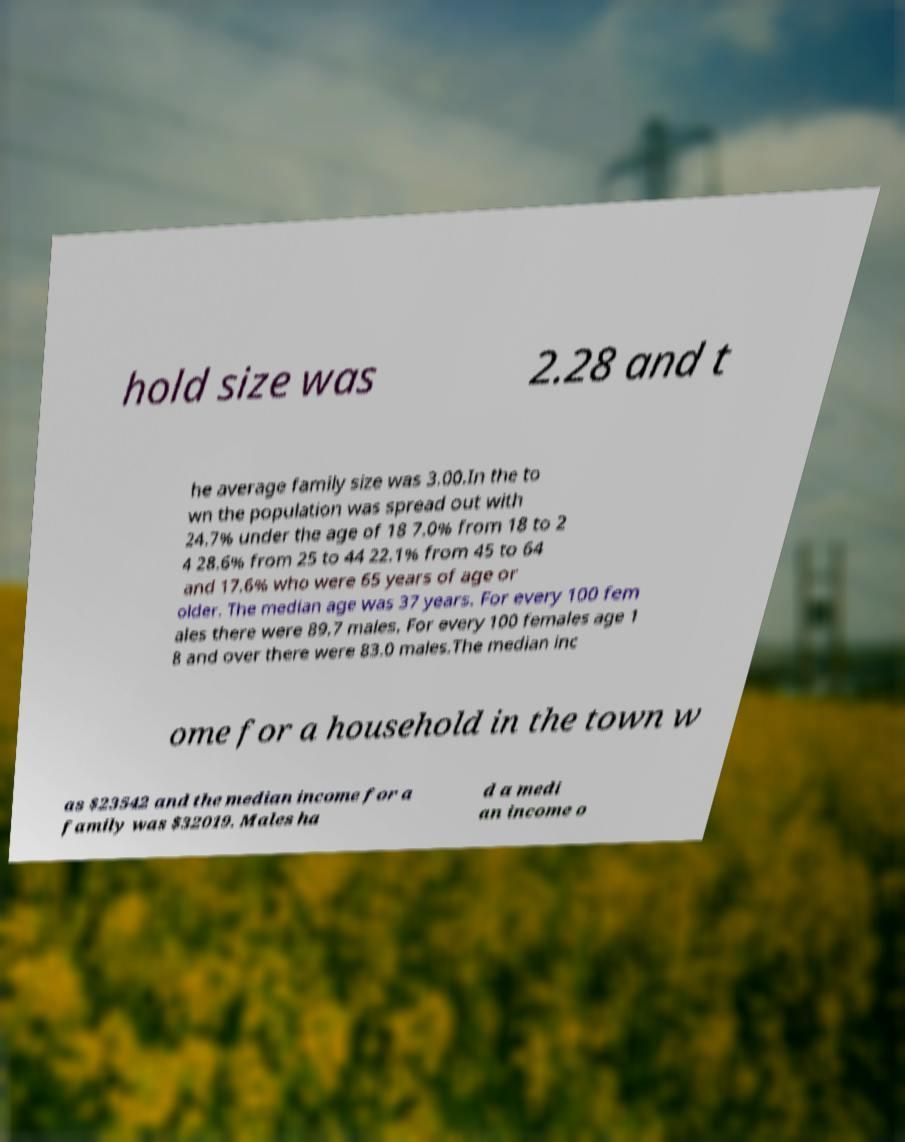There's text embedded in this image that I need extracted. Can you transcribe it verbatim? hold size was 2.28 and t he average family size was 3.00.In the to wn the population was spread out with 24.7% under the age of 18 7.0% from 18 to 2 4 28.6% from 25 to 44 22.1% from 45 to 64 and 17.6% who were 65 years of age or older. The median age was 37 years. For every 100 fem ales there were 89.7 males. For every 100 females age 1 8 and over there were 83.0 males.The median inc ome for a household in the town w as $23542 and the median income for a family was $32019. Males ha d a medi an income o 